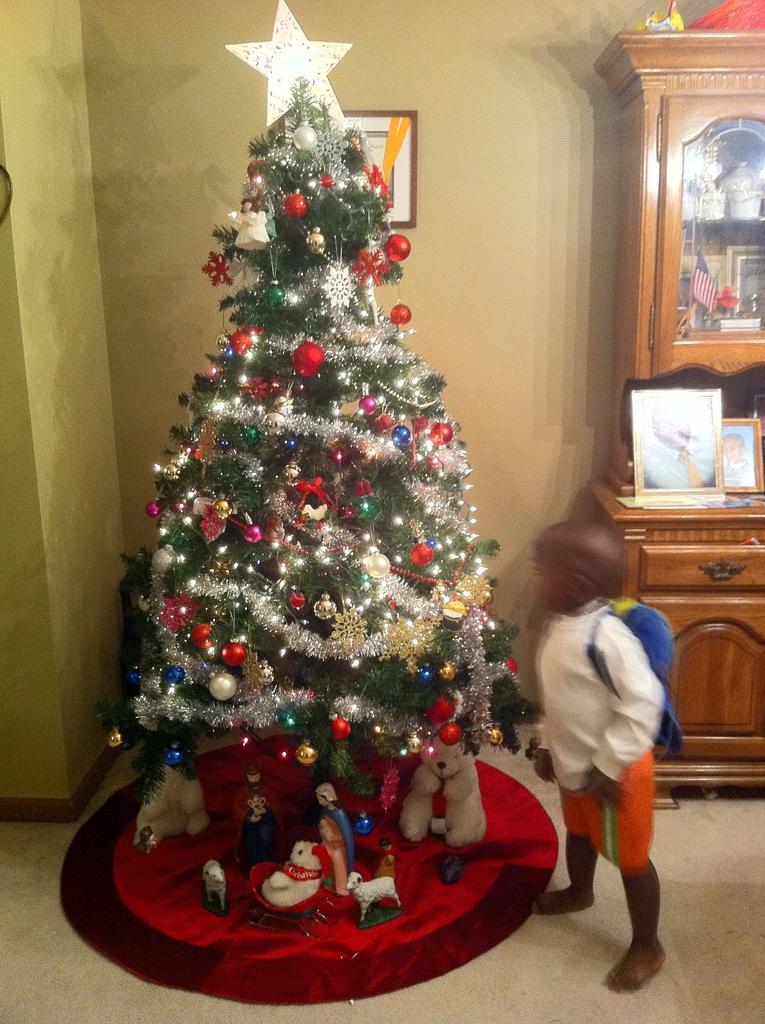In one or two sentences, can you explain what this image depicts? This image is taken indoors. At the bottom of the image there is a floor. In the background there is a wall with a picture frame on it. In the middle of the image there is a Christmas tree decorated with decorative items and a star and there are a few toys on the floor. A kid is standing on the floor. On the right side of the image there is a cupboard with many things. 